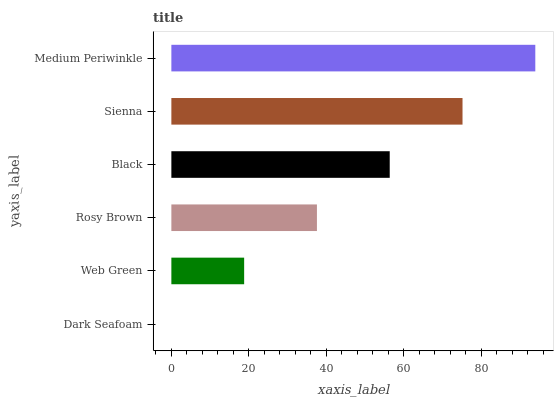Is Dark Seafoam the minimum?
Answer yes or no. Yes. Is Medium Periwinkle the maximum?
Answer yes or no. Yes. Is Web Green the minimum?
Answer yes or no. No. Is Web Green the maximum?
Answer yes or no. No. Is Web Green greater than Dark Seafoam?
Answer yes or no. Yes. Is Dark Seafoam less than Web Green?
Answer yes or no. Yes. Is Dark Seafoam greater than Web Green?
Answer yes or no. No. Is Web Green less than Dark Seafoam?
Answer yes or no. No. Is Black the high median?
Answer yes or no. Yes. Is Rosy Brown the low median?
Answer yes or no. Yes. Is Dark Seafoam the high median?
Answer yes or no. No. Is Medium Periwinkle the low median?
Answer yes or no. No. 